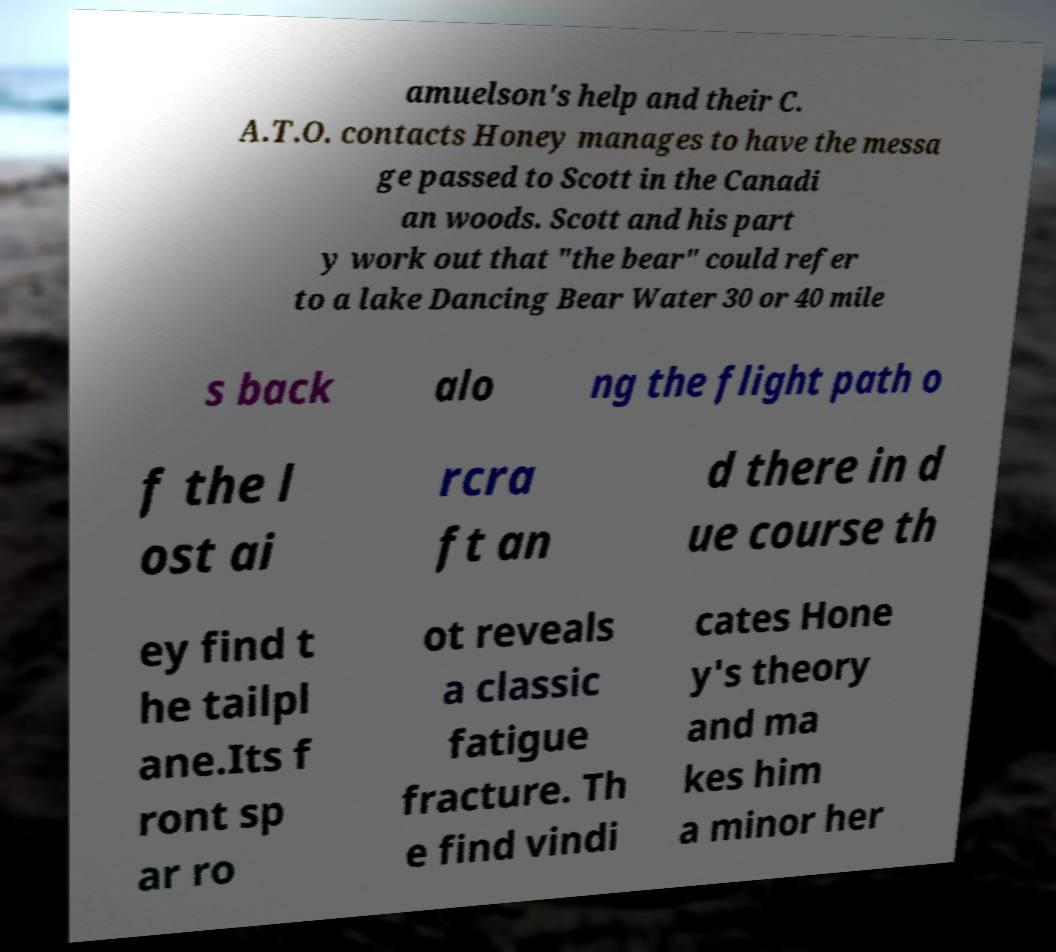For documentation purposes, I need the text within this image transcribed. Could you provide that? amuelson's help and their C. A.T.O. contacts Honey manages to have the messa ge passed to Scott in the Canadi an woods. Scott and his part y work out that "the bear" could refer to a lake Dancing Bear Water 30 or 40 mile s back alo ng the flight path o f the l ost ai rcra ft an d there in d ue course th ey find t he tailpl ane.Its f ront sp ar ro ot reveals a classic fatigue fracture. Th e find vindi cates Hone y's theory and ma kes him a minor her 